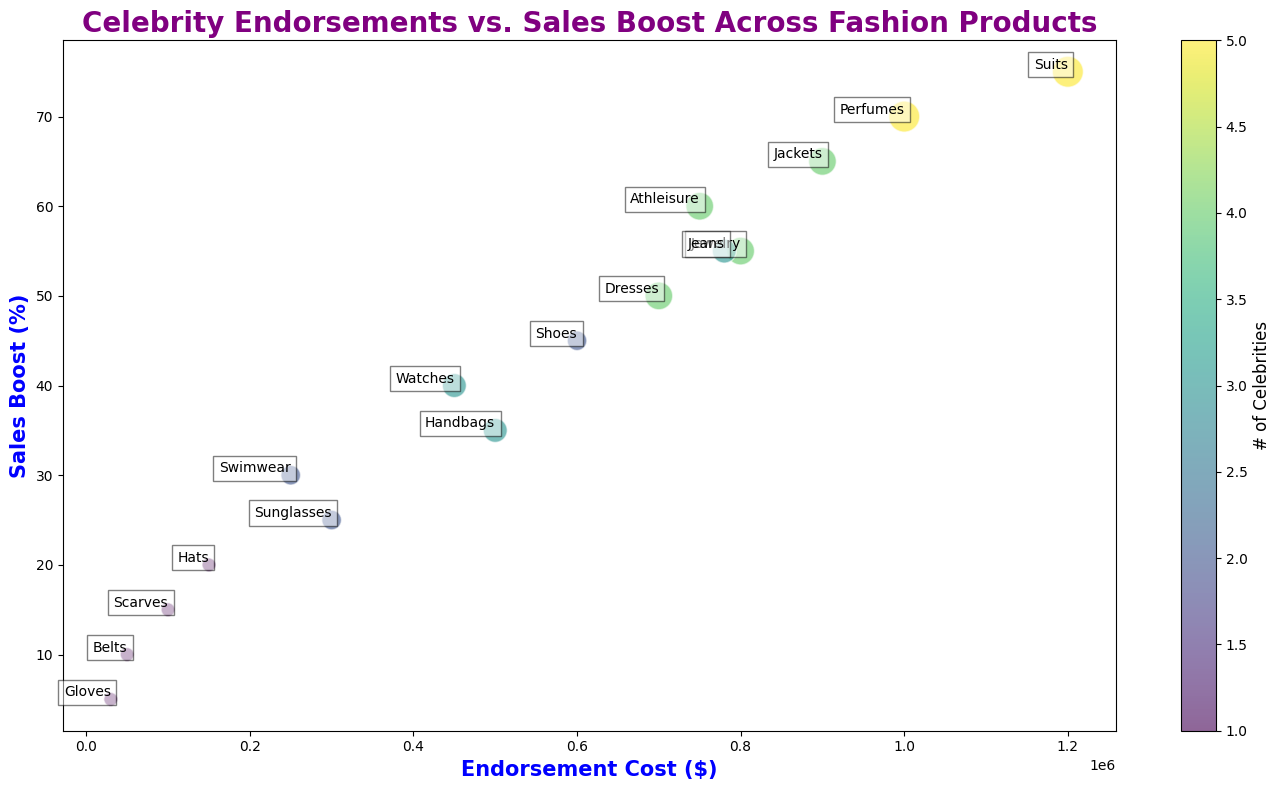How many products have exactly 4 celebrities endorsing them? By visually inspecting the number of products represented by bubbles of size corresponding to "4 celebrities", we identify Dresses, Jewelry, Athleisure, and Jackets.
Answer: 4 Which product has the highest sales boost and what is its endorsement cost? The product with the highest sales boost can be identified by the highest bubble on the vertical axis, i.e., Suits. The corresponding endorsement cost is $1,200,000.
Answer: Suits with $1,200,000 Which product has the smallest bubble, indicating the lowest number of celebrities endorsing it, and what is the sales boost for this product? The smallest bubbles indicate the products endorsed by only one celebrity. Gloves has the smallest bubble and the sales boost for this product is 5%.
Answer: Gloves with 5% What is the total endorsement cost for products that have a sales boost above 60%? Products with sales boost above 60% are Perfumes, Suits, and Jackets. Their endorsement costs are $1,000,000, $1,200,000, and $900,000 respectively. Summing these values gives $3,100,000.
Answer: $3,100,000 Compare the sales boost between Sunglasses and Swimwear. Which product has a higher sales boost and by how much? By locating Sunglasses and Swimwear on the vertical axis, Sunglasses has a sales boost of 25% and Swimwear has a sales boost of 30%. The difference is 5%.
Answer: Swimwear by 5% Which product is placed closest to the origin (0,0) on the plot and what does it imply in terms of sales boost and endorsement cost? By identifying the bubble closest to the bottom-left corner, Gloves is closest to the origin with a sales boost of 5% and an endorsement cost of $30,000.
Answer: Gloves with 5% sales boost and $30,000 endorsement cost For the product 'Handbags', what is its sales boost relative to its endorsement cost? Handbags' endorsement cost is $500,000 and the sales boost is 35%. This shows that a $500,000 endorsement results in a 35% sales boost.
Answer: 35% sales boost for $500,000 How does the number of celebrities affect the size of the bubble for the product 'Shoes' compared to 'Jewelry'? Shoes have 2 celebrities, and Jewelry has 4 celebrities. Jewelry is represented by a larger bubble size because it has more celebrities.
Answer: Jewelry has a larger bubble because it has more celebrities (4 vs. 2) 